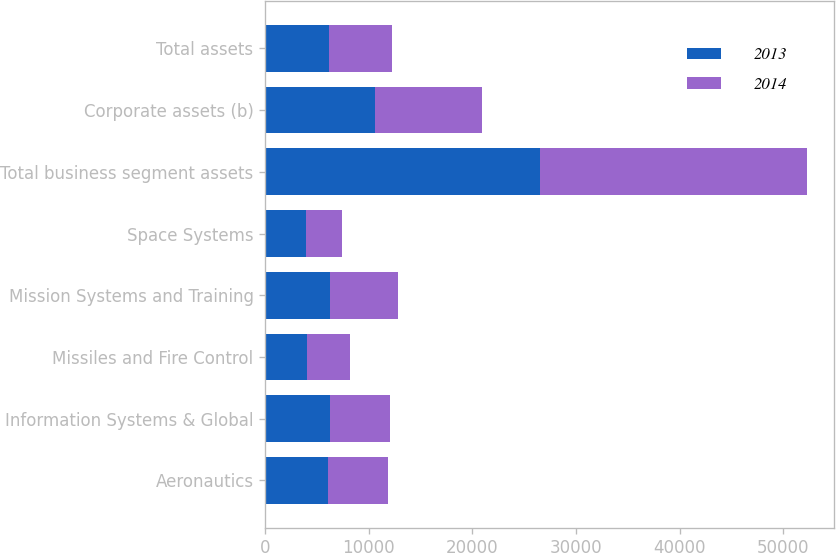Convert chart. <chart><loc_0><loc_0><loc_500><loc_500><stacked_bar_chart><ecel><fcel>Aeronautics<fcel>Information Systems & Global<fcel>Missiles and Fire Control<fcel>Mission Systems and Training<fcel>Space Systems<fcel>Total business segment assets<fcel>Corporate assets (b)<fcel>Total assets<nl><fcel>2013<fcel>6021<fcel>6228<fcel>4050<fcel>6277<fcel>3914<fcel>26490<fcel>10583<fcel>6124.5<nl><fcel>2014<fcel>5821<fcel>5798<fcel>4159<fcel>6512<fcel>3522<fcel>25812<fcel>10376<fcel>6124.5<nl></chart> 